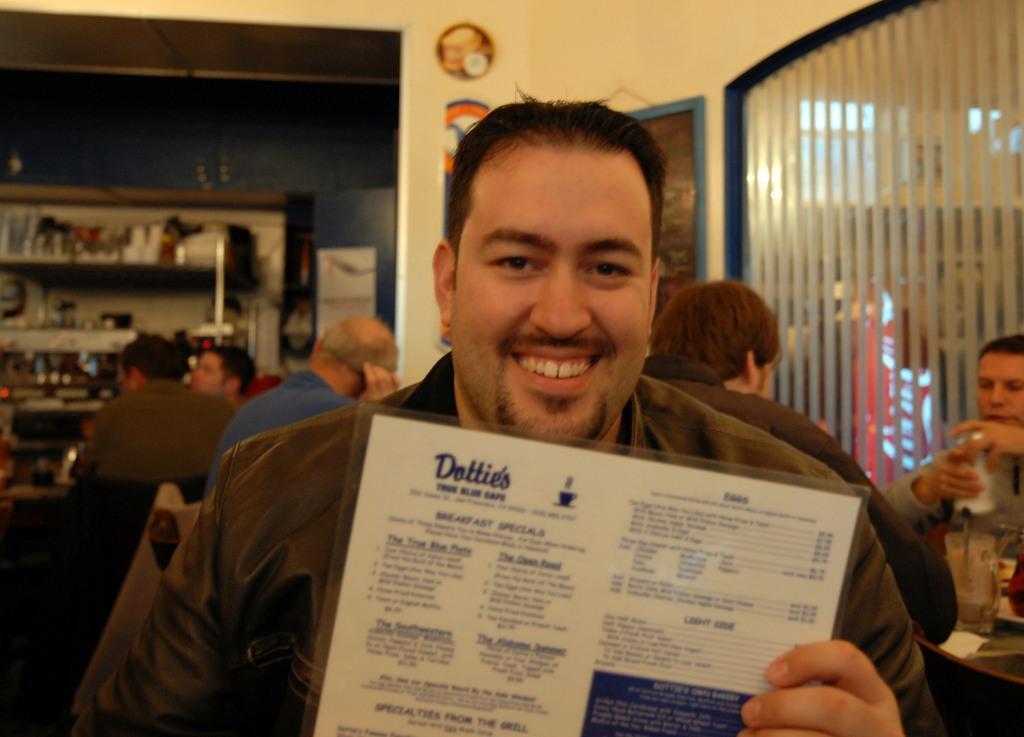Please provide a concise description of this image. This Image is clicked in a room. There are people sitting and there is a man in the front who is showing a card and smiling. There are the bottles and wine rack on the left side. There is a window blind on the right side and there are photo frames on the top. 